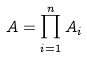Convert formula to latex. <formula><loc_0><loc_0><loc_500><loc_500>A = \prod _ { i = 1 } ^ { n } A _ { i }</formula> 